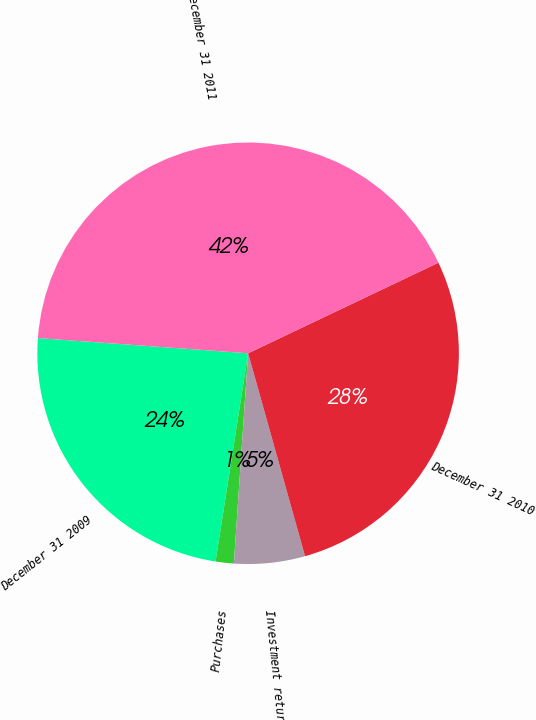Convert chart. <chart><loc_0><loc_0><loc_500><loc_500><pie_chart><fcel>December 31 2009<fcel>Purchases<fcel>Investment returns<fcel>December 31 2010<fcel>December 31 2011<nl><fcel>23.68%<fcel>1.39%<fcel>5.43%<fcel>27.72%<fcel>41.78%<nl></chart> 